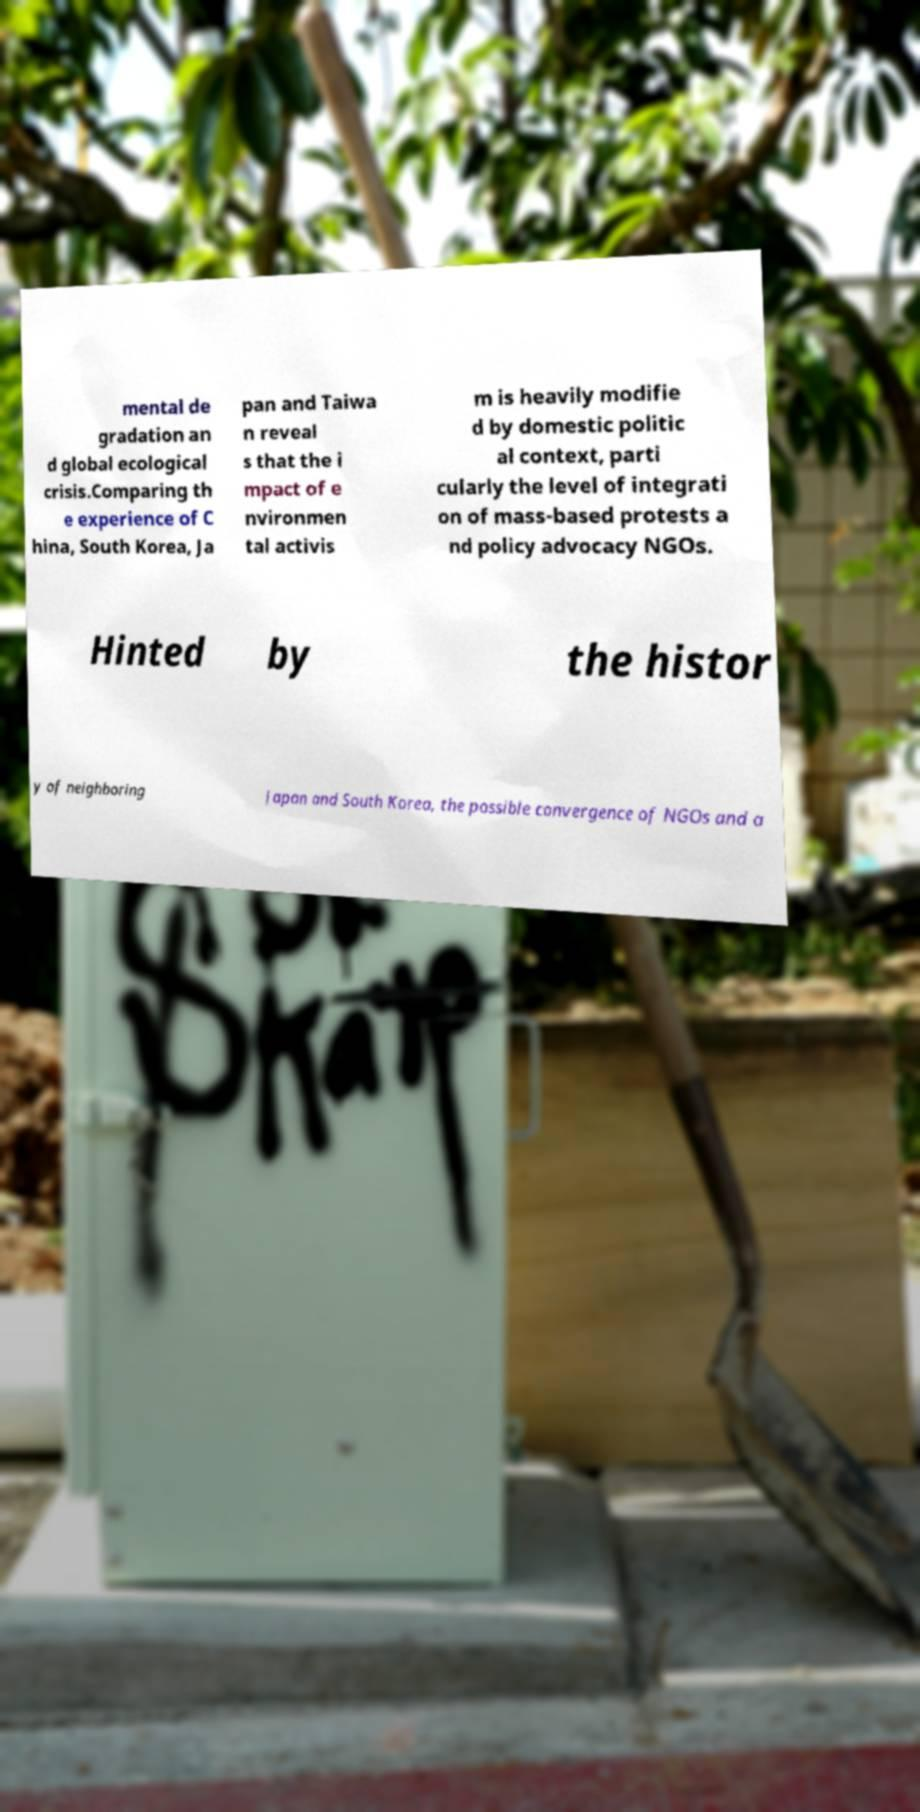I need the written content from this picture converted into text. Can you do that? mental de gradation an d global ecological crisis.Comparing th e experience of C hina, South Korea, Ja pan and Taiwa n reveal s that the i mpact of e nvironmen tal activis m is heavily modifie d by domestic politic al context, parti cularly the level of integrati on of mass-based protests a nd policy advocacy NGOs. Hinted by the histor y of neighboring Japan and South Korea, the possible convergence of NGOs and a 